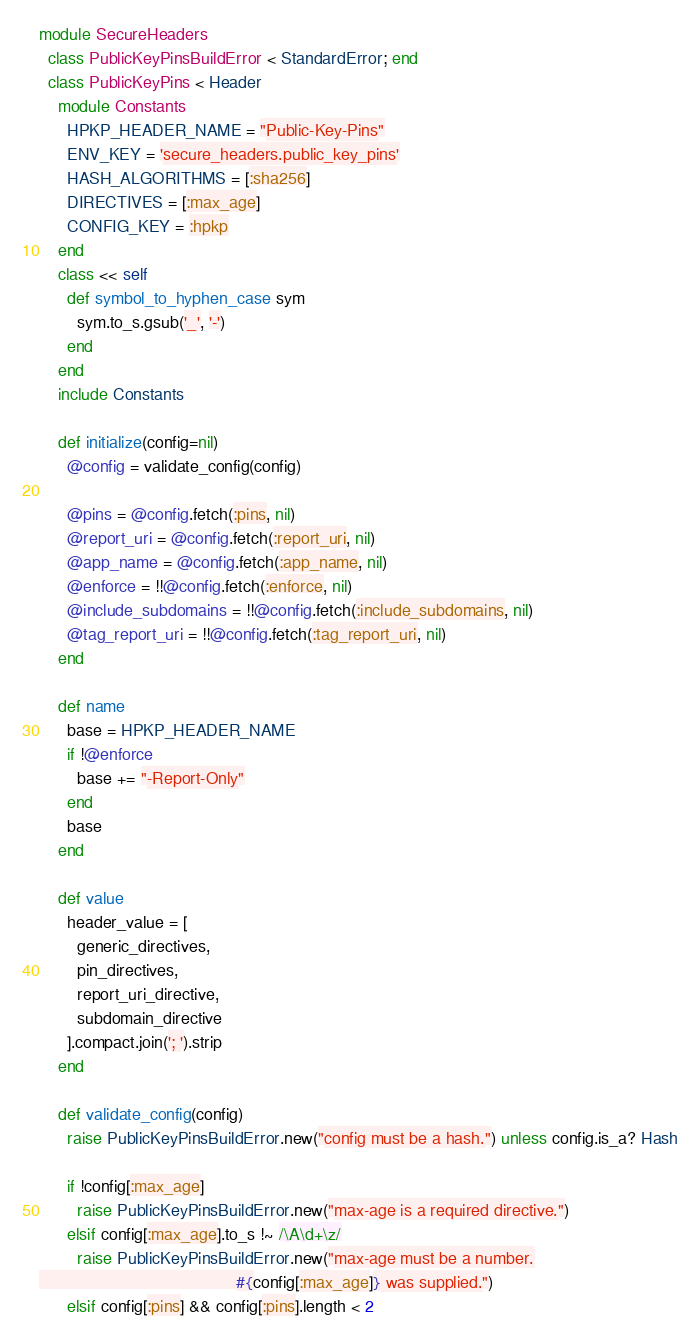<code> <loc_0><loc_0><loc_500><loc_500><_Ruby_>module SecureHeaders
  class PublicKeyPinsBuildError < StandardError; end
  class PublicKeyPins < Header
    module Constants
      HPKP_HEADER_NAME = "Public-Key-Pins"
      ENV_KEY = 'secure_headers.public_key_pins'
      HASH_ALGORITHMS = [:sha256]
      DIRECTIVES = [:max_age]
      CONFIG_KEY = :hpkp
    end
    class << self
      def symbol_to_hyphen_case sym
        sym.to_s.gsub('_', '-')
      end
    end
    include Constants

    def initialize(config=nil)
      @config = validate_config(config)

      @pins = @config.fetch(:pins, nil)
      @report_uri = @config.fetch(:report_uri, nil)
      @app_name = @config.fetch(:app_name, nil)
      @enforce = !!@config.fetch(:enforce, nil)
      @include_subdomains = !!@config.fetch(:include_subdomains, nil)
      @tag_report_uri = !!@config.fetch(:tag_report_uri, nil)
    end

    def name
      base = HPKP_HEADER_NAME
      if !@enforce
        base += "-Report-Only"
      end
      base
    end

    def value
      header_value = [
        generic_directives,
        pin_directives,
        report_uri_directive,
        subdomain_directive
      ].compact.join('; ').strip
    end

    def validate_config(config)
      raise PublicKeyPinsBuildError.new("config must be a hash.") unless config.is_a? Hash

      if !config[:max_age]
        raise PublicKeyPinsBuildError.new("max-age is a required directive.")
      elsif config[:max_age].to_s !~ /\A\d+\z/
        raise PublicKeyPinsBuildError.new("max-age must be a number.
                                          #{config[:max_age]} was supplied.")
      elsif config[:pins] && config[:pins].length < 2</code> 